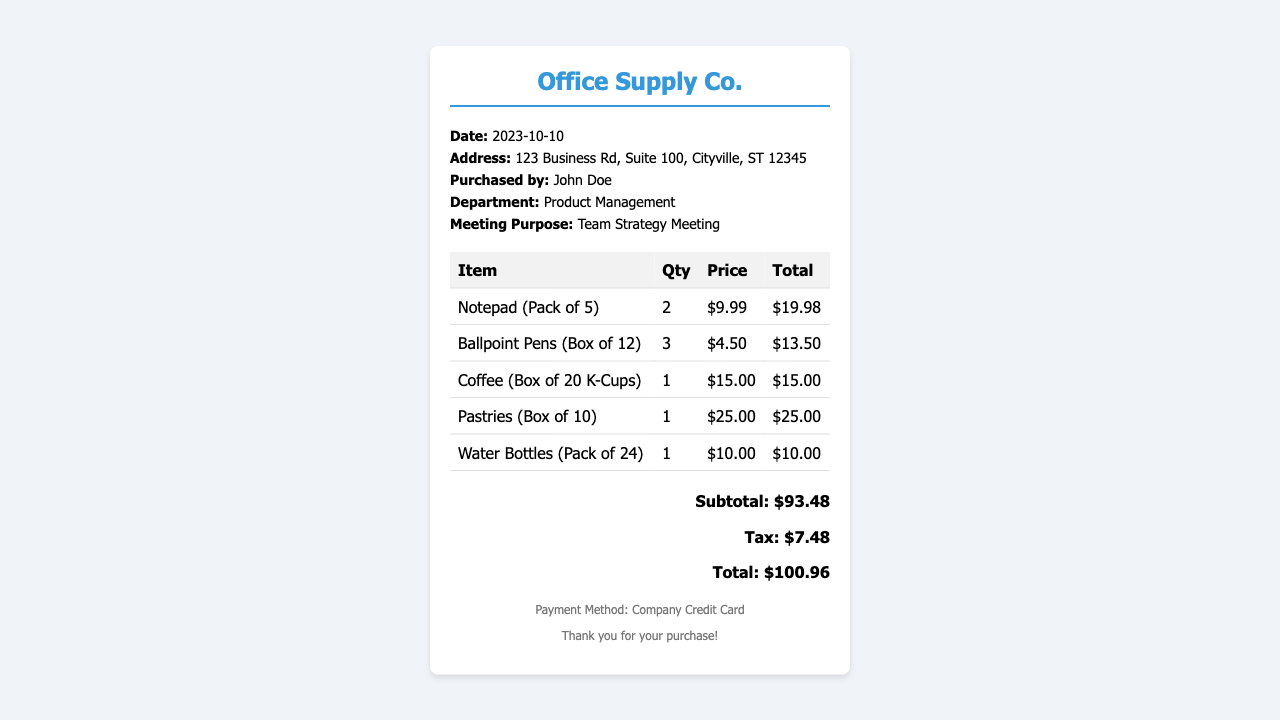What is the date of the purchase? The date of the purchase is specified in the document.
Answer: 2023-10-10 Who purchased the items? The document states the name of the individual who made the purchase.
Answer: John Doe What is the subtotal amount? The subtotal is detailed in the total section of the receipt.
Answer: $93.48 How many packs of notepads were purchased? The quantity of notepad packs is listed in the itemized table.
Answer: 2 What is the total amount spent including tax? The total is provided at the bottom of the receipt, which includes tax.
Answer: $100.96 What is the purpose of the meeting? The document mentions the meeting’s purpose in the information section.
Answer: Team Strategy Meeting What type of payment method was used? The payment method is indicated in the footer of the receipt.
Answer: Company Credit Card How many coffee boxes were purchased? The quantity of coffee boxes is shown in the item section of the receipt.
Answer: 1 What is the price of the pastries? The price of pastries is listed in the itemized details in the document.
Answer: $25.00 